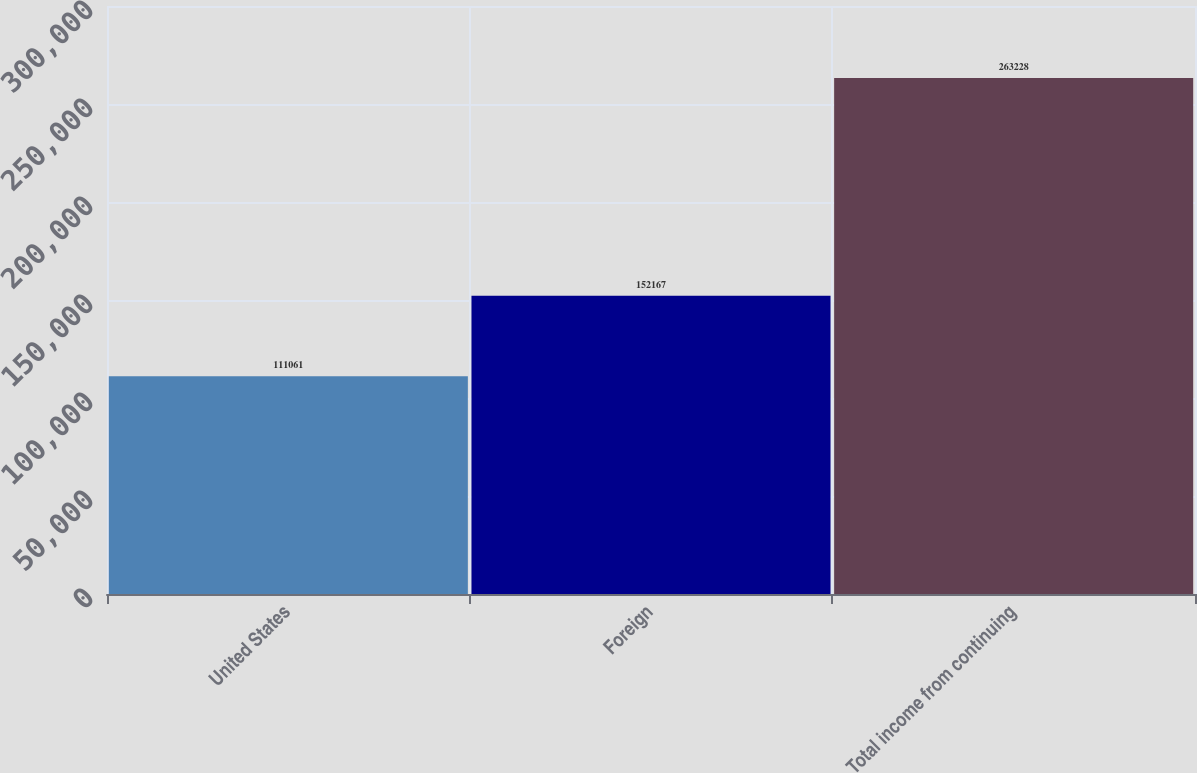<chart> <loc_0><loc_0><loc_500><loc_500><bar_chart><fcel>United States<fcel>Foreign<fcel>Total income from continuing<nl><fcel>111061<fcel>152167<fcel>263228<nl></chart> 